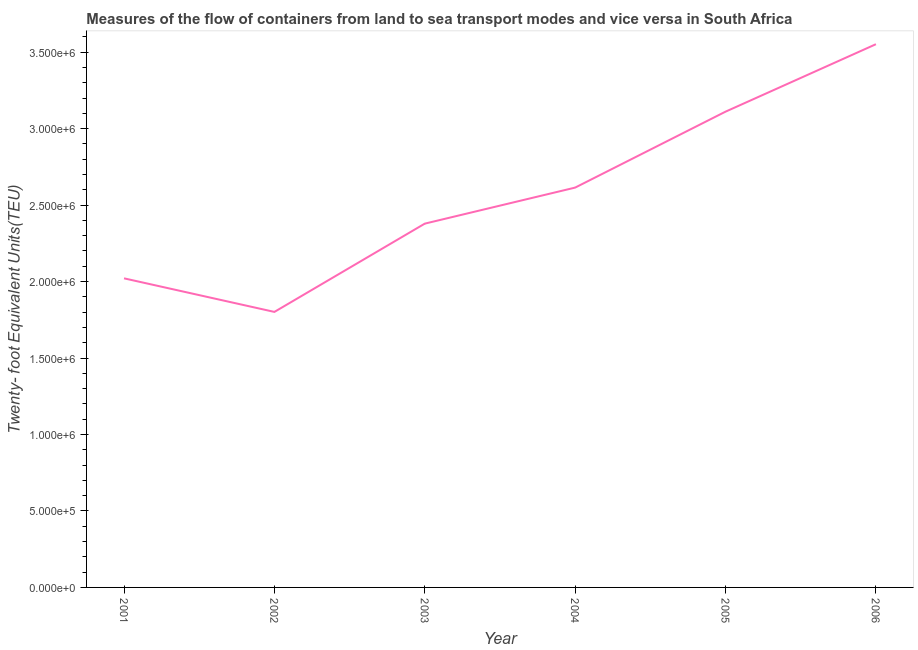What is the container port traffic in 2002?
Your answer should be compact. 1.80e+06. Across all years, what is the maximum container port traffic?
Ensure brevity in your answer.  3.55e+06. Across all years, what is the minimum container port traffic?
Your response must be concise. 1.80e+06. In which year was the container port traffic maximum?
Ensure brevity in your answer.  2006. What is the sum of the container port traffic?
Provide a short and direct response. 1.55e+07. What is the difference between the container port traffic in 2002 and 2004?
Provide a succinct answer. -8.13e+05. What is the average container port traffic per year?
Keep it short and to the point. 2.58e+06. What is the median container port traffic?
Your response must be concise. 2.50e+06. In how many years, is the container port traffic greater than 100000 TEU?
Provide a succinct answer. 6. What is the ratio of the container port traffic in 2001 to that in 2006?
Provide a short and direct response. 0.57. What is the difference between the highest and the second highest container port traffic?
Provide a succinct answer. 4.41e+05. Is the sum of the container port traffic in 2003 and 2006 greater than the maximum container port traffic across all years?
Keep it short and to the point. Yes. What is the difference between the highest and the lowest container port traffic?
Offer a very short reply. 1.75e+06. Does the container port traffic monotonically increase over the years?
Provide a succinct answer. No. How many lines are there?
Make the answer very short. 1. What is the difference between two consecutive major ticks on the Y-axis?
Provide a succinct answer. 5.00e+05. What is the title of the graph?
Offer a very short reply. Measures of the flow of containers from land to sea transport modes and vice versa in South Africa. What is the label or title of the X-axis?
Provide a short and direct response. Year. What is the label or title of the Y-axis?
Give a very brief answer. Twenty- foot Equivalent Units(TEU). What is the Twenty- foot Equivalent Units(TEU) of 2001?
Give a very brief answer. 2.02e+06. What is the Twenty- foot Equivalent Units(TEU) of 2002?
Give a very brief answer. 1.80e+06. What is the Twenty- foot Equivalent Units(TEU) in 2003?
Your answer should be compact. 2.38e+06. What is the Twenty- foot Equivalent Units(TEU) of 2004?
Provide a short and direct response. 2.61e+06. What is the Twenty- foot Equivalent Units(TEU) in 2005?
Your answer should be very brief. 3.11e+06. What is the Twenty- foot Equivalent Units(TEU) of 2006?
Give a very brief answer. 3.55e+06. What is the difference between the Twenty- foot Equivalent Units(TEU) in 2001 and 2002?
Your answer should be very brief. 2.20e+05. What is the difference between the Twenty- foot Equivalent Units(TEU) in 2001 and 2003?
Provide a succinct answer. -3.58e+05. What is the difference between the Twenty- foot Equivalent Units(TEU) in 2001 and 2004?
Provide a short and direct response. -5.93e+05. What is the difference between the Twenty- foot Equivalent Units(TEU) in 2001 and 2005?
Offer a terse response. -1.09e+06. What is the difference between the Twenty- foot Equivalent Units(TEU) in 2001 and 2006?
Give a very brief answer. -1.53e+06. What is the difference between the Twenty- foot Equivalent Units(TEU) in 2002 and 2003?
Offer a terse response. -5.77e+05. What is the difference between the Twenty- foot Equivalent Units(TEU) in 2002 and 2004?
Your response must be concise. -8.13e+05. What is the difference between the Twenty- foot Equivalent Units(TEU) in 2002 and 2005?
Provide a short and direct response. -1.31e+06. What is the difference between the Twenty- foot Equivalent Units(TEU) in 2002 and 2006?
Provide a short and direct response. -1.75e+06. What is the difference between the Twenty- foot Equivalent Units(TEU) in 2003 and 2004?
Ensure brevity in your answer.  -2.36e+05. What is the difference between the Twenty- foot Equivalent Units(TEU) in 2003 and 2005?
Keep it short and to the point. -7.32e+05. What is the difference between the Twenty- foot Equivalent Units(TEU) in 2003 and 2006?
Offer a terse response. -1.17e+06. What is the difference between the Twenty- foot Equivalent Units(TEU) in 2004 and 2005?
Provide a short and direct response. -4.97e+05. What is the difference between the Twenty- foot Equivalent Units(TEU) in 2004 and 2006?
Offer a very short reply. -9.38e+05. What is the difference between the Twenty- foot Equivalent Units(TEU) in 2005 and 2006?
Your answer should be compact. -4.41e+05. What is the ratio of the Twenty- foot Equivalent Units(TEU) in 2001 to that in 2002?
Provide a succinct answer. 1.12. What is the ratio of the Twenty- foot Equivalent Units(TEU) in 2001 to that in 2004?
Provide a succinct answer. 0.77. What is the ratio of the Twenty- foot Equivalent Units(TEU) in 2001 to that in 2005?
Your response must be concise. 0.65. What is the ratio of the Twenty- foot Equivalent Units(TEU) in 2001 to that in 2006?
Provide a succinct answer. 0.57. What is the ratio of the Twenty- foot Equivalent Units(TEU) in 2002 to that in 2003?
Give a very brief answer. 0.76. What is the ratio of the Twenty- foot Equivalent Units(TEU) in 2002 to that in 2004?
Your answer should be compact. 0.69. What is the ratio of the Twenty- foot Equivalent Units(TEU) in 2002 to that in 2005?
Ensure brevity in your answer.  0.58. What is the ratio of the Twenty- foot Equivalent Units(TEU) in 2002 to that in 2006?
Ensure brevity in your answer.  0.51. What is the ratio of the Twenty- foot Equivalent Units(TEU) in 2003 to that in 2004?
Your answer should be very brief. 0.91. What is the ratio of the Twenty- foot Equivalent Units(TEU) in 2003 to that in 2005?
Keep it short and to the point. 0.77. What is the ratio of the Twenty- foot Equivalent Units(TEU) in 2003 to that in 2006?
Keep it short and to the point. 0.67. What is the ratio of the Twenty- foot Equivalent Units(TEU) in 2004 to that in 2005?
Provide a short and direct response. 0.84. What is the ratio of the Twenty- foot Equivalent Units(TEU) in 2004 to that in 2006?
Your answer should be compact. 0.74. What is the ratio of the Twenty- foot Equivalent Units(TEU) in 2005 to that in 2006?
Keep it short and to the point. 0.88. 